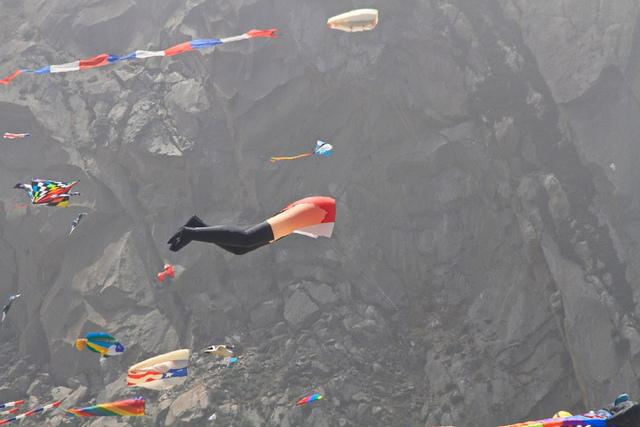What is the most popular kite shape?

Choices:
A) snoopy
B) diamond/delta/box
C) dragon
D) cat diamond/delta/box 